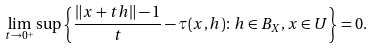<formula> <loc_0><loc_0><loc_500><loc_500>\lim _ { t \rightarrow 0 ^ { + } } \sup \left \{ \frac { \| x + t h \| - 1 } { t } - \tau ( x , h ) \colon h \in B _ { X } , x \in U \right \} = 0 .</formula> 